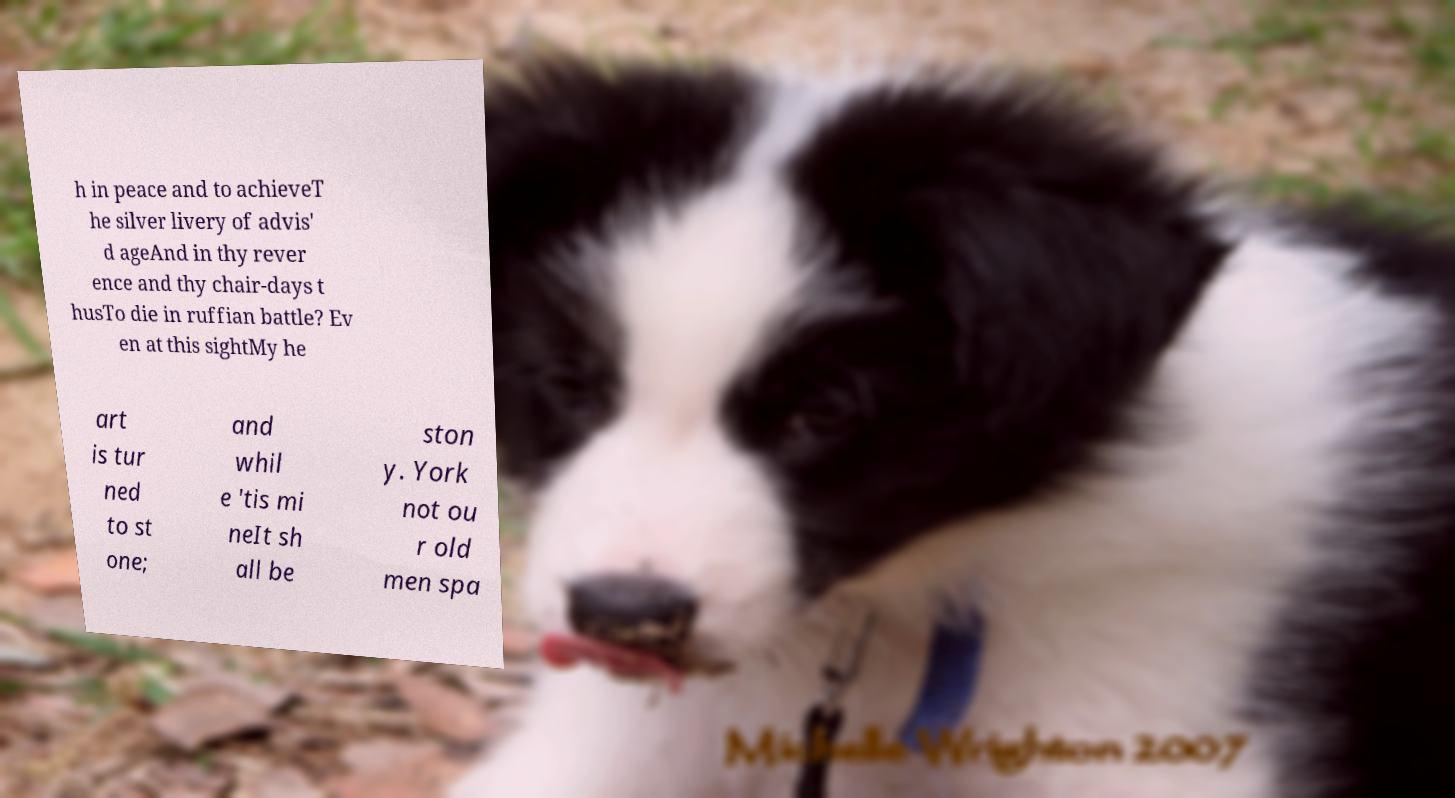There's text embedded in this image that I need extracted. Can you transcribe it verbatim? h in peace and to achieveT he silver livery of advis' d ageAnd in thy rever ence and thy chair-days t husTo die in ruffian battle? Ev en at this sightMy he art is tur ned to st one; and whil e 'tis mi neIt sh all be ston y. York not ou r old men spa 